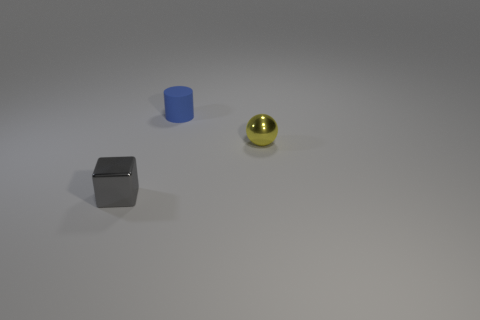Is there anything else that has the same shape as the blue rubber thing?
Keep it short and to the point. No. There is a tiny object that is right of the object that is behind the small sphere; are there any things in front of it?
Give a very brief answer. Yes. How many large things are either rubber objects or gray objects?
Give a very brief answer. 0. There is a metal thing that is the same size as the sphere; what is its color?
Offer a very short reply. Gray. There is a metal sphere; what number of tiny things are behind it?
Your response must be concise. 1. Is there a thing made of the same material as the small gray cube?
Keep it short and to the point. Yes. There is a object that is behind the tiny ball; what color is it?
Your answer should be compact. Blue. Are there an equal number of small spheres that are behind the tiny yellow sphere and tiny yellow balls that are in front of the gray thing?
Offer a terse response. Yes. There is a object in front of the small metal object to the right of the gray thing; what is it made of?
Provide a succinct answer. Metal. What number of things are cubes or small metal things left of the rubber thing?
Offer a terse response. 1. 